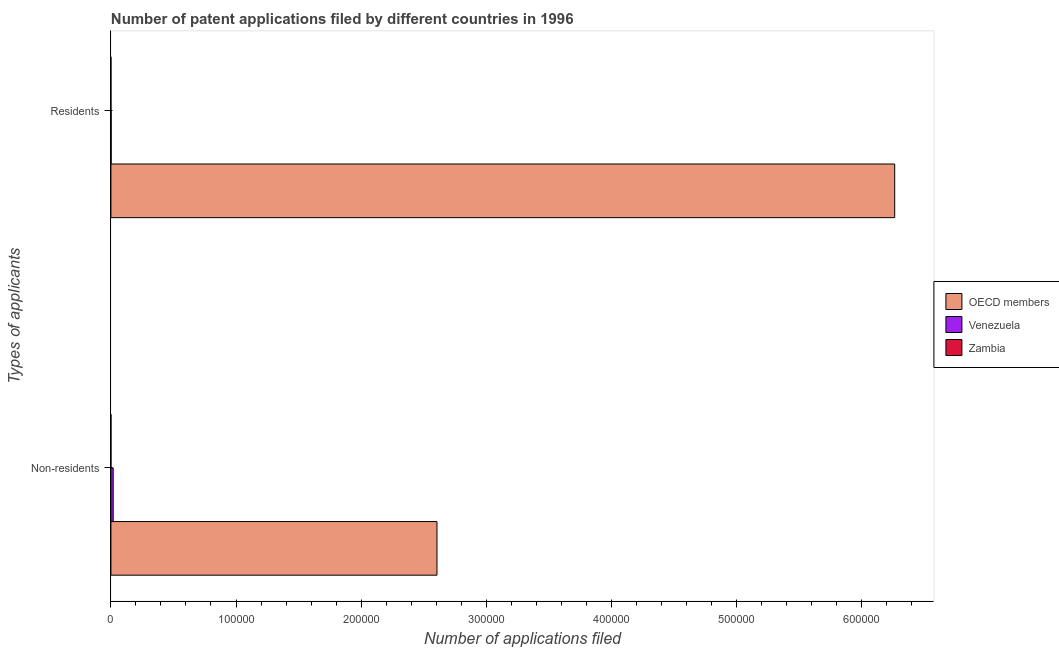How many groups of bars are there?
Give a very brief answer. 2. Are the number of bars on each tick of the Y-axis equal?
Offer a terse response. Yes. What is the label of the 1st group of bars from the top?
Your answer should be compact. Residents. What is the number of patent applications by residents in OECD members?
Offer a very short reply. 6.27e+05. Across all countries, what is the maximum number of patent applications by residents?
Your answer should be very brief. 6.27e+05. In which country was the number of patent applications by residents minimum?
Your answer should be very brief. Zambia. What is the total number of patent applications by non residents in the graph?
Your answer should be very brief. 2.63e+05. What is the difference between the number of patent applications by residents in Zambia and that in Venezuela?
Give a very brief answer. -176. What is the difference between the number of patent applications by non residents in Venezuela and the number of patent applications by residents in Zambia?
Your response must be concise. 1816. What is the average number of patent applications by residents per country?
Your answer should be compact. 2.09e+05. What is the difference between the number of patent applications by residents and number of patent applications by non residents in Zambia?
Offer a terse response. -30. What is the ratio of the number of patent applications by residents in Venezuela to that in OECD members?
Ensure brevity in your answer.  0. Is the number of patent applications by residents in Zambia less than that in OECD members?
Your response must be concise. Yes. In how many countries, is the number of patent applications by residents greater than the average number of patent applications by residents taken over all countries?
Ensure brevity in your answer.  1. What does the 1st bar from the top in Residents represents?
Provide a short and direct response. Zambia. What does the 1st bar from the bottom in Residents represents?
Provide a short and direct response. OECD members. How many bars are there?
Provide a succinct answer. 6. Where does the legend appear in the graph?
Make the answer very short. Center right. How many legend labels are there?
Provide a short and direct response. 3. What is the title of the graph?
Your answer should be compact. Number of patent applications filed by different countries in 1996. Does "Marshall Islands" appear as one of the legend labels in the graph?
Ensure brevity in your answer.  No. What is the label or title of the X-axis?
Your answer should be compact. Number of applications filed. What is the label or title of the Y-axis?
Offer a very short reply. Types of applicants. What is the Number of applications filed in OECD members in Non-residents?
Your response must be concise. 2.61e+05. What is the Number of applications filed of Venezuela in Non-residents?
Your answer should be compact. 1822. What is the Number of applications filed of Zambia in Non-residents?
Ensure brevity in your answer.  36. What is the Number of applications filed in OECD members in Residents?
Make the answer very short. 6.27e+05. What is the Number of applications filed of Venezuela in Residents?
Ensure brevity in your answer.  182. What is the Number of applications filed of Zambia in Residents?
Give a very brief answer. 6. Across all Types of applicants, what is the maximum Number of applications filed of OECD members?
Make the answer very short. 6.27e+05. Across all Types of applicants, what is the maximum Number of applications filed of Venezuela?
Offer a very short reply. 1822. Across all Types of applicants, what is the maximum Number of applications filed of Zambia?
Give a very brief answer. 36. Across all Types of applicants, what is the minimum Number of applications filed of OECD members?
Offer a terse response. 2.61e+05. Across all Types of applicants, what is the minimum Number of applications filed in Venezuela?
Your response must be concise. 182. Across all Types of applicants, what is the minimum Number of applications filed of Zambia?
Provide a short and direct response. 6. What is the total Number of applications filed of OECD members in the graph?
Keep it short and to the point. 8.87e+05. What is the total Number of applications filed of Venezuela in the graph?
Offer a terse response. 2004. What is the total Number of applications filed of Zambia in the graph?
Your answer should be very brief. 42. What is the difference between the Number of applications filed of OECD members in Non-residents and that in Residents?
Your answer should be compact. -3.66e+05. What is the difference between the Number of applications filed in Venezuela in Non-residents and that in Residents?
Provide a succinct answer. 1640. What is the difference between the Number of applications filed of OECD members in Non-residents and the Number of applications filed of Venezuela in Residents?
Your response must be concise. 2.60e+05. What is the difference between the Number of applications filed in OECD members in Non-residents and the Number of applications filed in Zambia in Residents?
Ensure brevity in your answer.  2.61e+05. What is the difference between the Number of applications filed in Venezuela in Non-residents and the Number of applications filed in Zambia in Residents?
Make the answer very short. 1816. What is the average Number of applications filed in OECD members per Types of applicants?
Offer a terse response. 4.44e+05. What is the average Number of applications filed in Venezuela per Types of applicants?
Make the answer very short. 1002. What is the average Number of applications filed in Zambia per Types of applicants?
Your answer should be compact. 21. What is the difference between the Number of applications filed of OECD members and Number of applications filed of Venezuela in Non-residents?
Ensure brevity in your answer.  2.59e+05. What is the difference between the Number of applications filed of OECD members and Number of applications filed of Zambia in Non-residents?
Offer a very short reply. 2.61e+05. What is the difference between the Number of applications filed of Venezuela and Number of applications filed of Zambia in Non-residents?
Offer a terse response. 1786. What is the difference between the Number of applications filed of OECD members and Number of applications filed of Venezuela in Residents?
Your answer should be compact. 6.26e+05. What is the difference between the Number of applications filed in OECD members and Number of applications filed in Zambia in Residents?
Give a very brief answer. 6.27e+05. What is the difference between the Number of applications filed of Venezuela and Number of applications filed of Zambia in Residents?
Your answer should be compact. 176. What is the ratio of the Number of applications filed of OECD members in Non-residents to that in Residents?
Provide a short and direct response. 0.42. What is the ratio of the Number of applications filed in Venezuela in Non-residents to that in Residents?
Give a very brief answer. 10.01. What is the difference between the highest and the second highest Number of applications filed of OECD members?
Give a very brief answer. 3.66e+05. What is the difference between the highest and the second highest Number of applications filed in Venezuela?
Your answer should be very brief. 1640. What is the difference between the highest and the lowest Number of applications filed in OECD members?
Make the answer very short. 3.66e+05. What is the difference between the highest and the lowest Number of applications filed in Venezuela?
Ensure brevity in your answer.  1640. What is the difference between the highest and the lowest Number of applications filed in Zambia?
Provide a succinct answer. 30. 